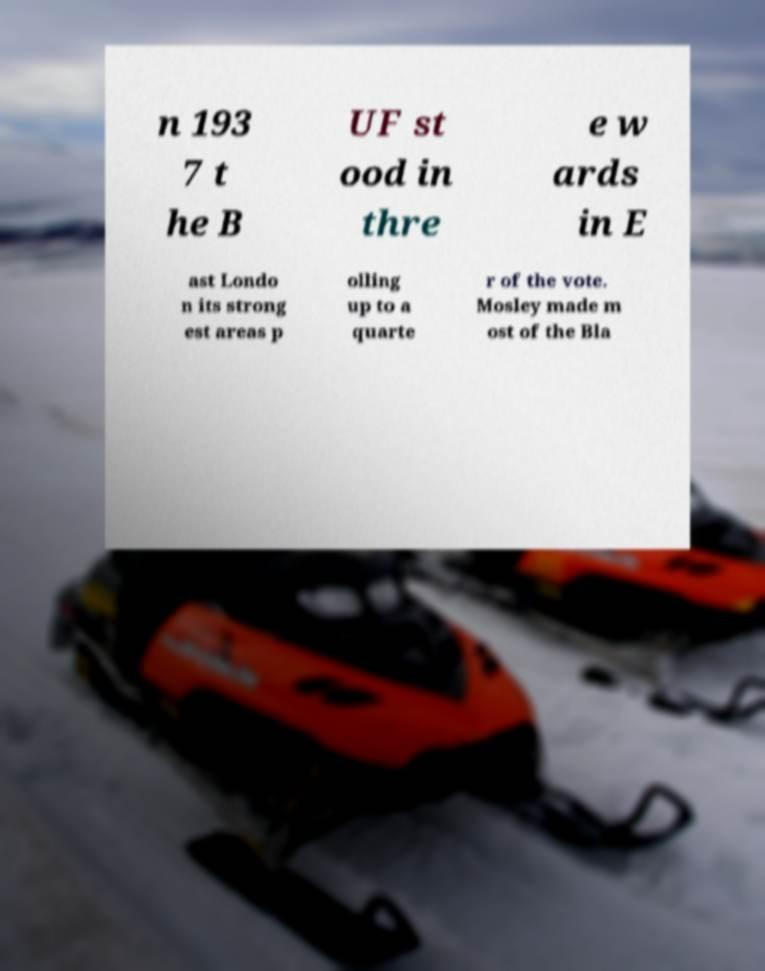Please read and relay the text visible in this image. What does it say? n 193 7 t he B UF st ood in thre e w ards in E ast Londo n its strong est areas p olling up to a quarte r of the vote. Mosley made m ost of the Bla 